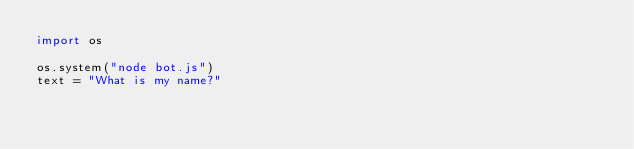<code> <loc_0><loc_0><loc_500><loc_500><_Python_>import os

os.system("node bot.js")
text = "What is my name?"

</code> 